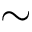<formula> <loc_0><loc_0><loc_500><loc_500>\sim</formula> 